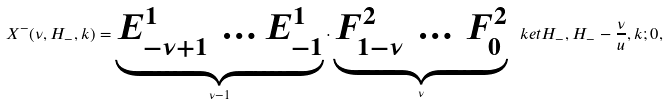<formula> <loc_0><loc_0><loc_500><loc_500>X ^ { - } ( \nu , H _ { - } , k ) = \underbrace { E ^ { 1 } _ { - \nu + 1 } \, \dots E ^ { 1 } _ { - 1 } } _ { \nu - 1 } \cdot \underbrace { F ^ { 2 } _ { 1 - \nu } \, \dots \, F ^ { 2 } _ { 0 } } _ { \nu } \ k e t { H _ { - } , H _ { - } - \frac { \nu } { u } , k ; 0 } ,</formula> 